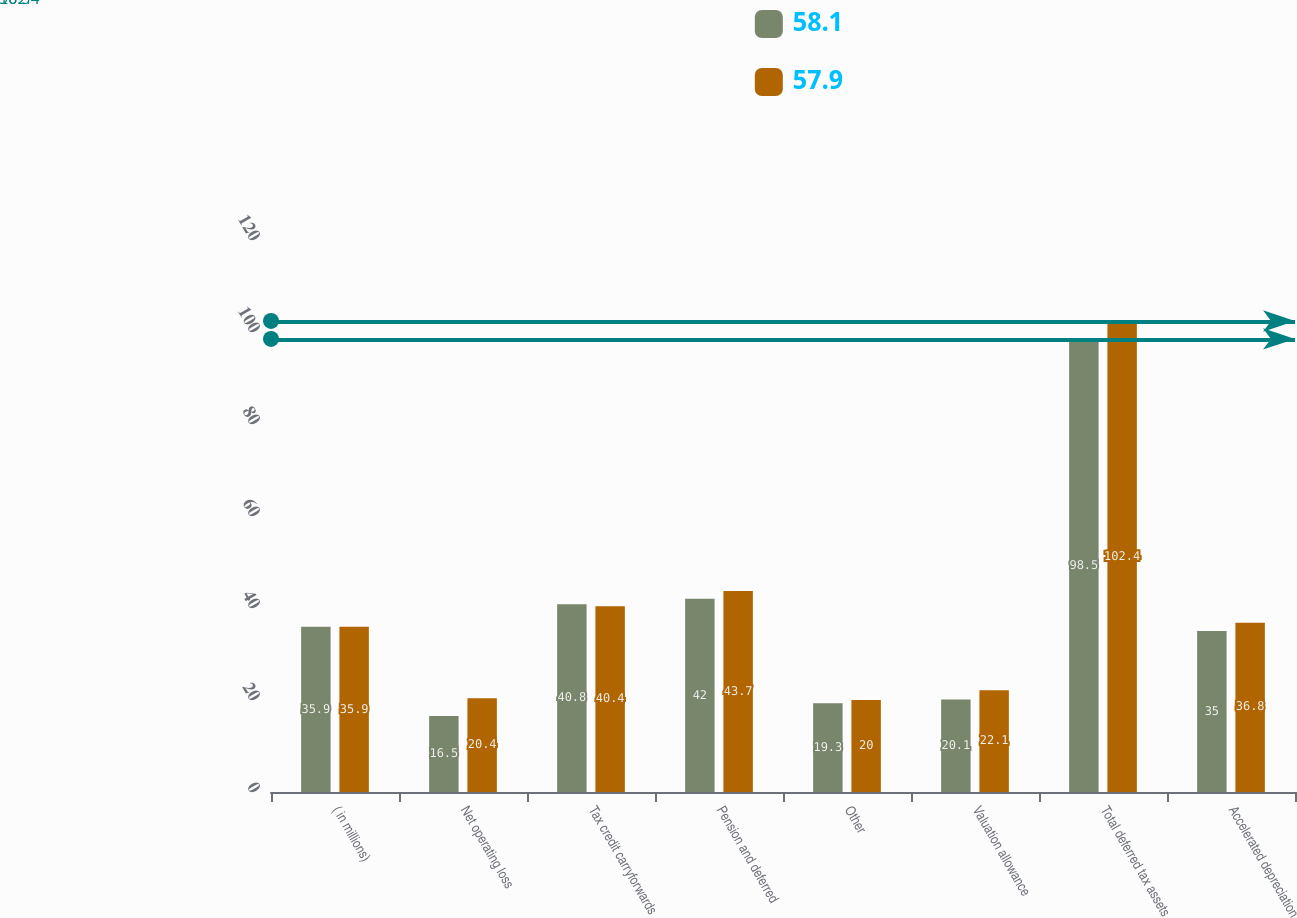<chart> <loc_0><loc_0><loc_500><loc_500><stacked_bar_chart><ecel><fcel>( in millions)<fcel>Net operating loss<fcel>Tax credit carryforwards<fcel>Pension and deferred<fcel>Other<fcel>Valuation allowance<fcel>Total deferred tax assets<fcel>Accelerated depreciation<nl><fcel>58.1<fcel>35.9<fcel>16.5<fcel>40.8<fcel>42<fcel>19.3<fcel>20.1<fcel>98.5<fcel>35<nl><fcel>57.9<fcel>35.9<fcel>20.4<fcel>40.4<fcel>43.7<fcel>20<fcel>22.1<fcel>102.4<fcel>36.8<nl></chart> 